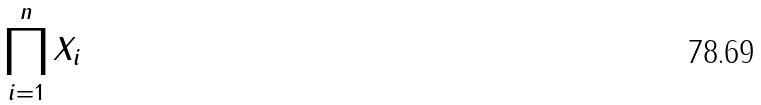<formula> <loc_0><loc_0><loc_500><loc_500>\prod _ { i = 1 } ^ { n } X _ { i }</formula> 